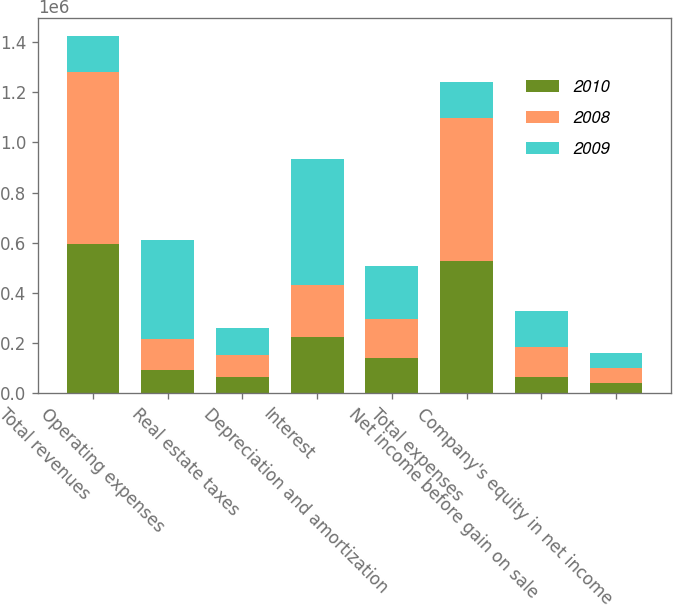Convert chart to OTSL. <chart><loc_0><loc_0><loc_500><loc_500><stacked_bar_chart><ecel><fcel>Total revenues<fcel>Operating expenses<fcel>Real estate taxes<fcel>Interest<fcel>Depreciation and amortization<fcel>Total expenses<fcel>Net income before gain on sale<fcel>Company's equity in net income<nl><fcel>2010<fcel>593159<fcel>94515<fcel>66588<fcel>224766<fcel>141284<fcel>528258<fcel>64901<fcel>39607<nl><fcel>2008<fcel>689087<fcel>120215<fcel>84827<fcel>208295<fcel>156470<fcel>569807<fcel>119280<fcel>62878<nl><fcel>2009<fcel>141747<fcel>395872<fcel>109002<fcel>499710<fcel>210425<fcel>141747<fcel>142210<fcel>59961<nl></chart> 